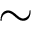Convert formula to latex. <formula><loc_0><loc_0><loc_500><loc_500>\sim</formula> 